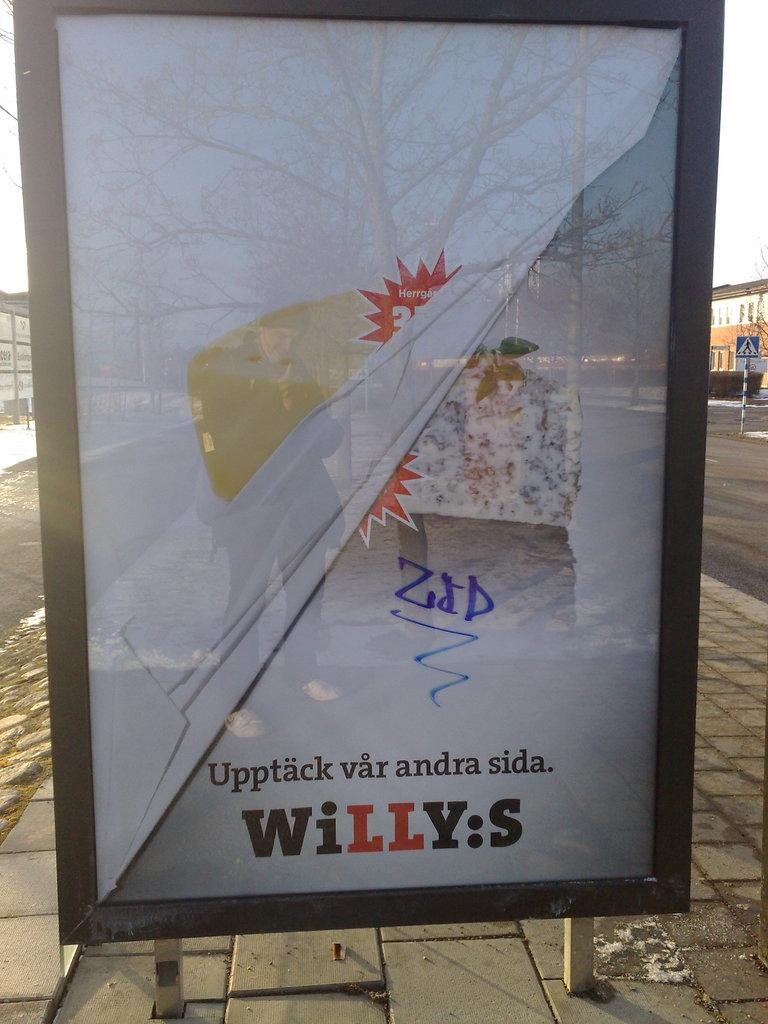<image>
Give a short and clear explanation of the subsequent image. A poster in a glass case on the sidewalk with some foreign words and says WILLY:S at the bottom in red and black. 